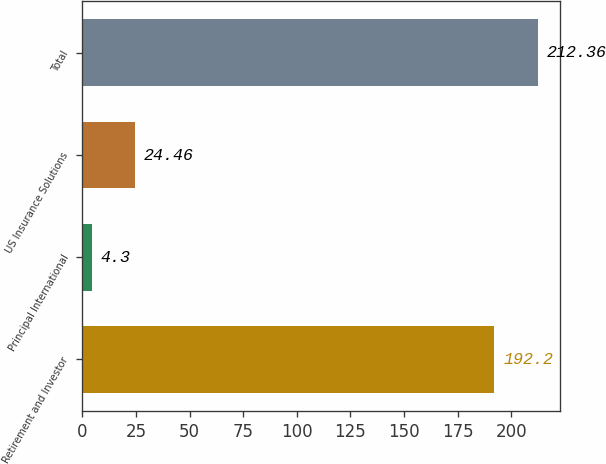<chart> <loc_0><loc_0><loc_500><loc_500><bar_chart><fcel>Retirement and Investor<fcel>Principal International<fcel>US Insurance Solutions<fcel>Total<nl><fcel>192.2<fcel>4.3<fcel>24.46<fcel>212.36<nl></chart> 